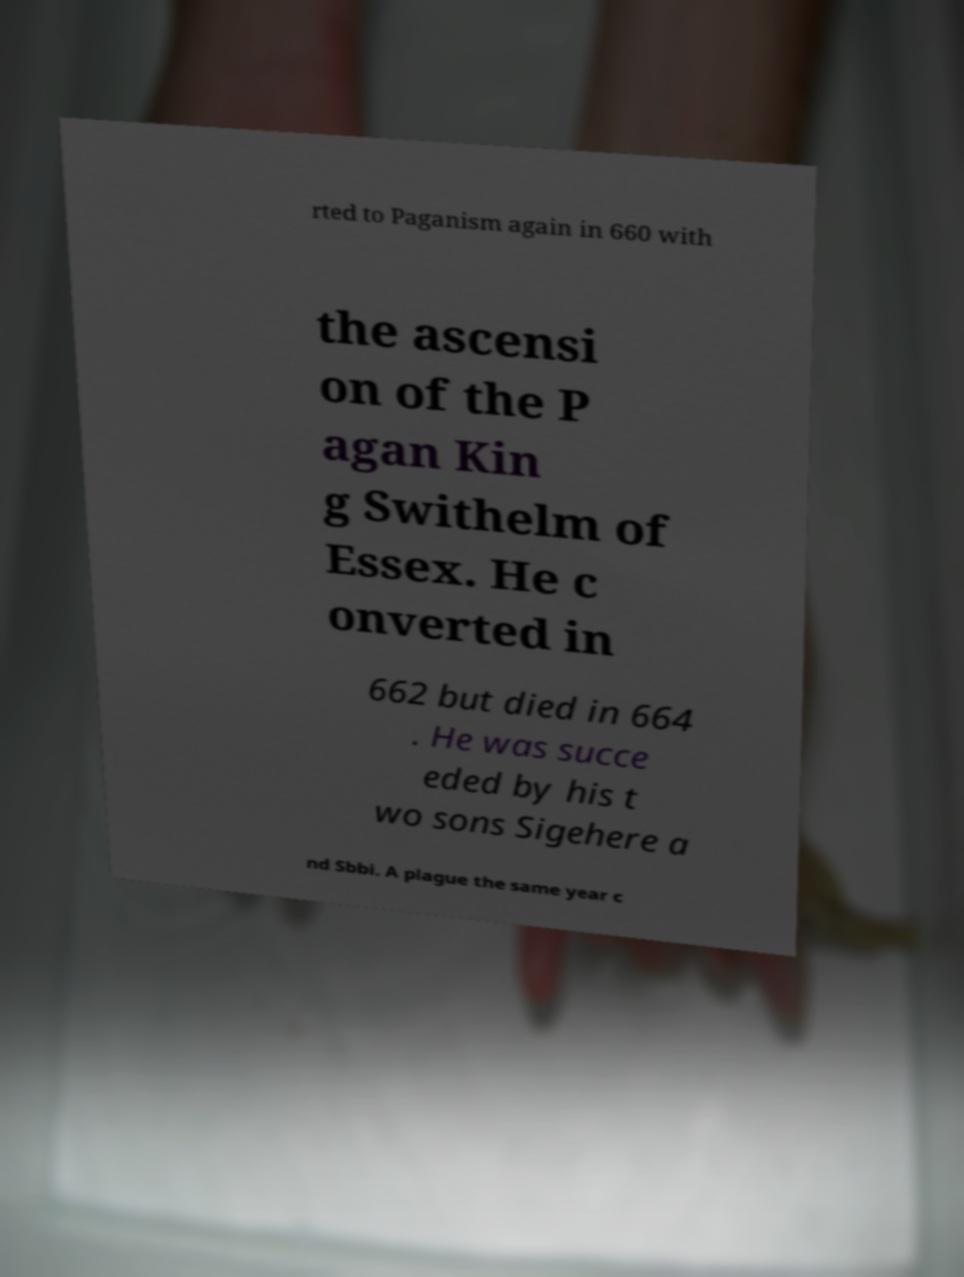Could you assist in decoding the text presented in this image and type it out clearly? rted to Paganism again in 660 with the ascensi on of the P agan Kin g Swithelm of Essex. He c onverted in 662 but died in 664 . He was succe eded by his t wo sons Sigehere a nd Sbbi. A plague the same year c 